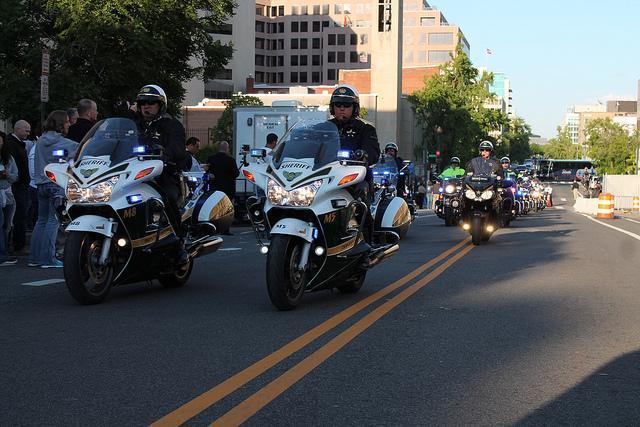How many yellow lines are on the road?
Give a very brief answer. 2. How many people can be seen?
Give a very brief answer. 5. How many motorcycles can be seen?
Give a very brief answer. 4. 